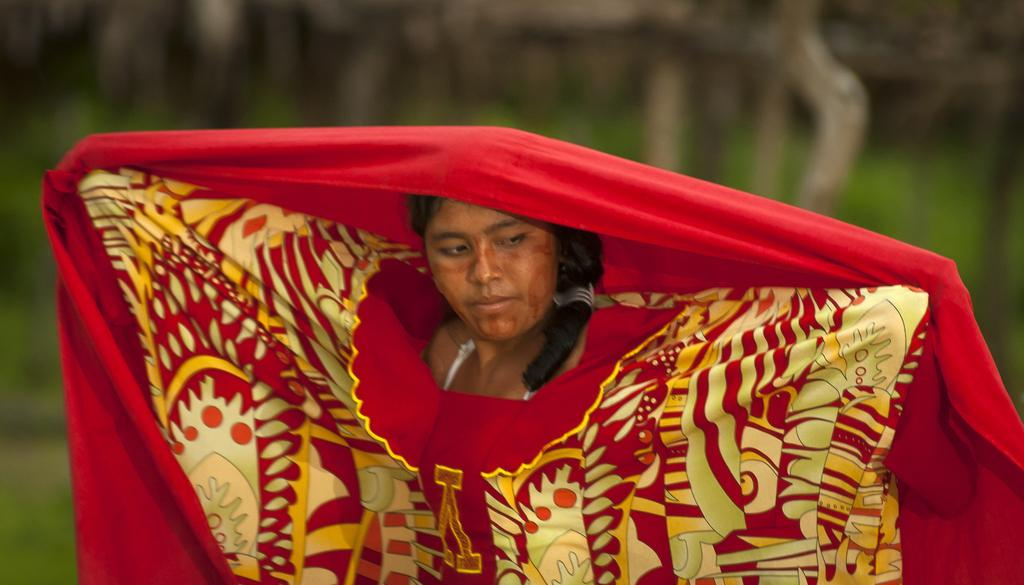Who or what is the main subject of the image? There is a person in the image. What is the person wearing? The person is wearing a red and yellow color dress. Can you describe the background of the image? The background of the image is blurred. What type of hope can be seen in the person's eyes in the image? There is no indication of hope or emotions in the person's eyes in the image, as the focus is on their clothing and the blurred background. 